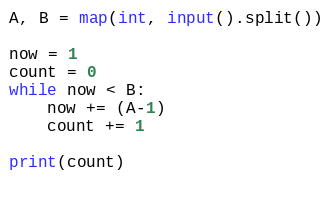<code> <loc_0><loc_0><loc_500><loc_500><_Python_>A, B = map(int, input().split())

now = 1
count = 0
while now < B:
    now += (A-1)
    count += 1

print(count)
    
    
</code> 